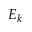Convert formula to latex. <formula><loc_0><loc_0><loc_500><loc_500>E _ { k }</formula> 